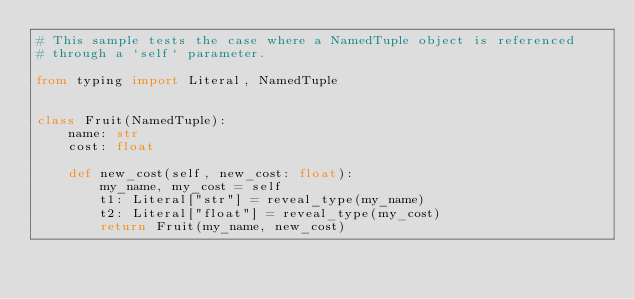Convert code to text. <code><loc_0><loc_0><loc_500><loc_500><_Python_># This sample tests the case where a NamedTuple object is referenced
# through a `self` parameter.

from typing import Literal, NamedTuple


class Fruit(NamedTuple):
    name: str
    cost: float

    def new_cost(self, new_cost: float):
        my_name, my_cost = self
        t1: Literal["str"] = reveal_type(my_name)
        t2: Literal["float"] = reveal_type(my_cost)
        return Fruit(my_name, new_cost)
</code> 